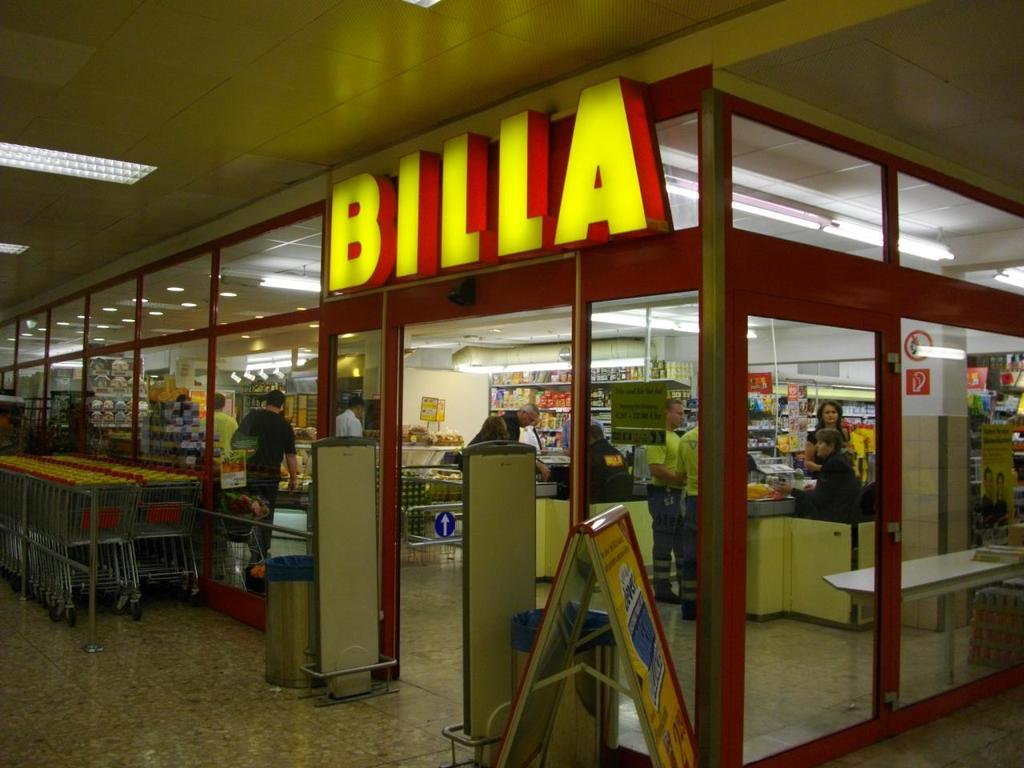<image>
Provide a brief description of the given image. A BILLA store has many shopping carts available outside 